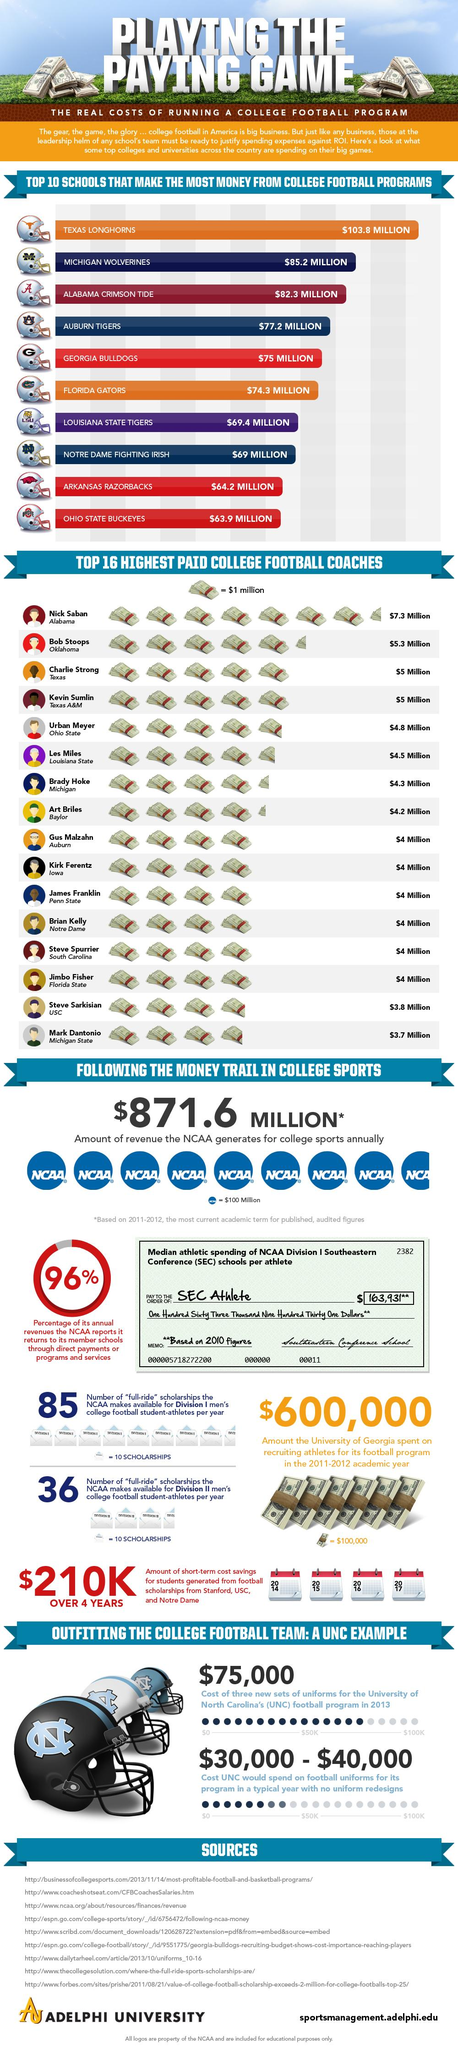Mention a couple of crucial points in this snapshot. The combined payment of Nick Saban and Bob Stoops is $12.6 million. I declare that the combined payment for Art Briles and Kirk Ferentz is $8.2 million. According to the available data, the total amount of money made by the Florida Gators and Auburn Tigers from their college football programs is $151.5 million. The total amount of money made by the Texas Longhorns and Michigan Wolverines college football programs is $189 million. The cost of three new sets of uniforms for the University of North Carolina's football program in 2013 was $75,000. 